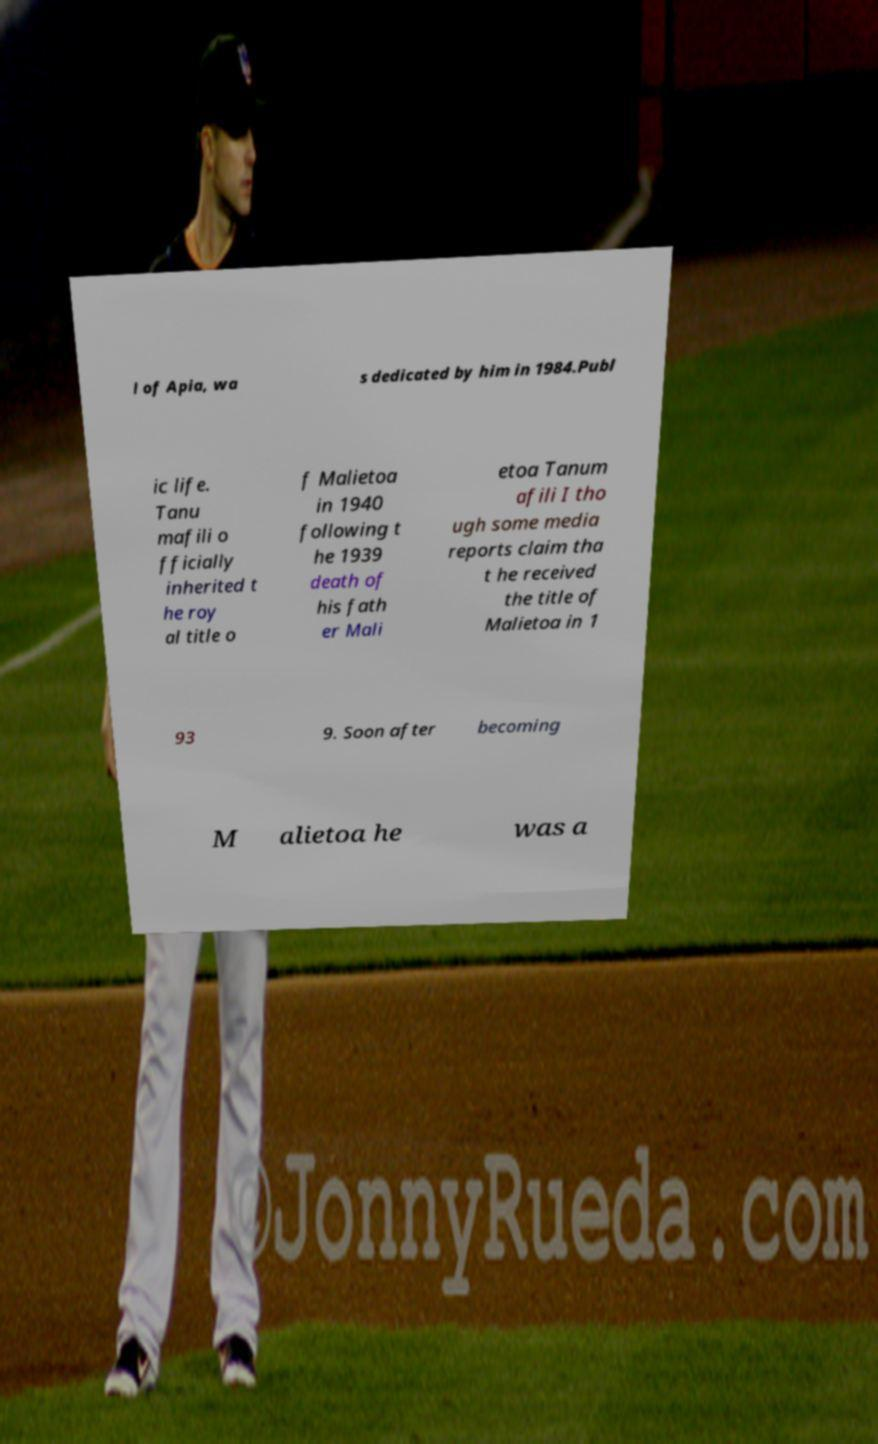Could you extract and type out the text from this image? l of Apia, wa s dedicated by him in 1984.Publ ic life. Tanu mafili o fficially inherited t he roy al title o f Malietoa in 1940 following t he 1939 death of his fath er Mali etoa Tanum afili I tho ugh some media reports claim tha t he received the title of Malietoa in 1 93 9. Soon after becoming M alietoa he was a 